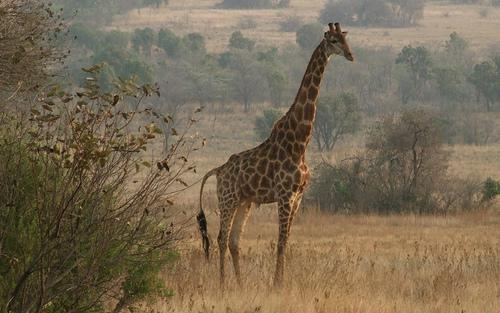Question: what type of animal is in the photo?
Choices:
A. Giraffe.
B. Gazelle.
C. Elephant.
D. Lions.
Answer with the letter. Answer: A Question: how would a giraffe reach food located on the ground?
Choices:
A. Bending down.
B. Someone handing it to them.
C. By lowering head.
D. Laying down.
Answer with the letter. Answer: C Question: why do giraffes probably have horns on their heads?
Choices:
A. Fighting.
B. For defense.
C. Protection.
D. Security.
Answer with the letter. Answer: B Question: who may have taken this photo?
Choices:
A. Mom.
B. Dad.
C. Wildlife photographer.
D. Child.
Answer with the letter. Answer: C Question: what is covering the field?
Choices:
A. Dirt.
B. Gravel.
C. Grass.
D. Dry grass.
Answer with the letter. Answer: D 